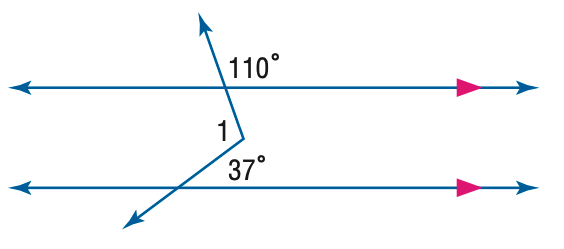Answer the mathemtical geometry problem and directly provide the correct option letter.
Question: Find m \angle 1 in the figure.
Choices: A: 37 B: 107 C: 110 D: 143 B 